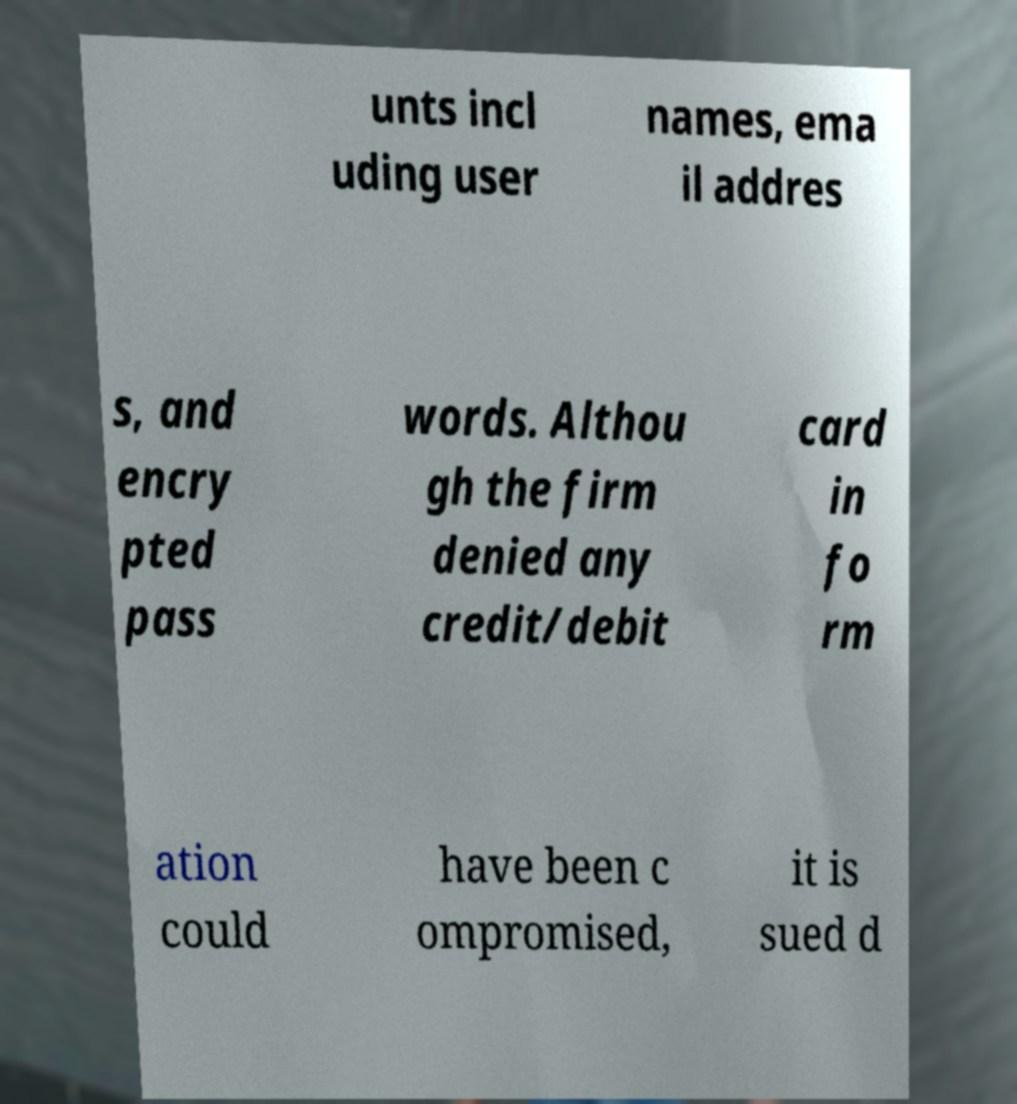Can you accurately transcribe the text from the provided image for me? unts incl uding user names, ema il addres s, and encry pted pass words. Althou gh the firm denied any credit/debit card in fo rm ation could have been c ompromised, it is sued d 